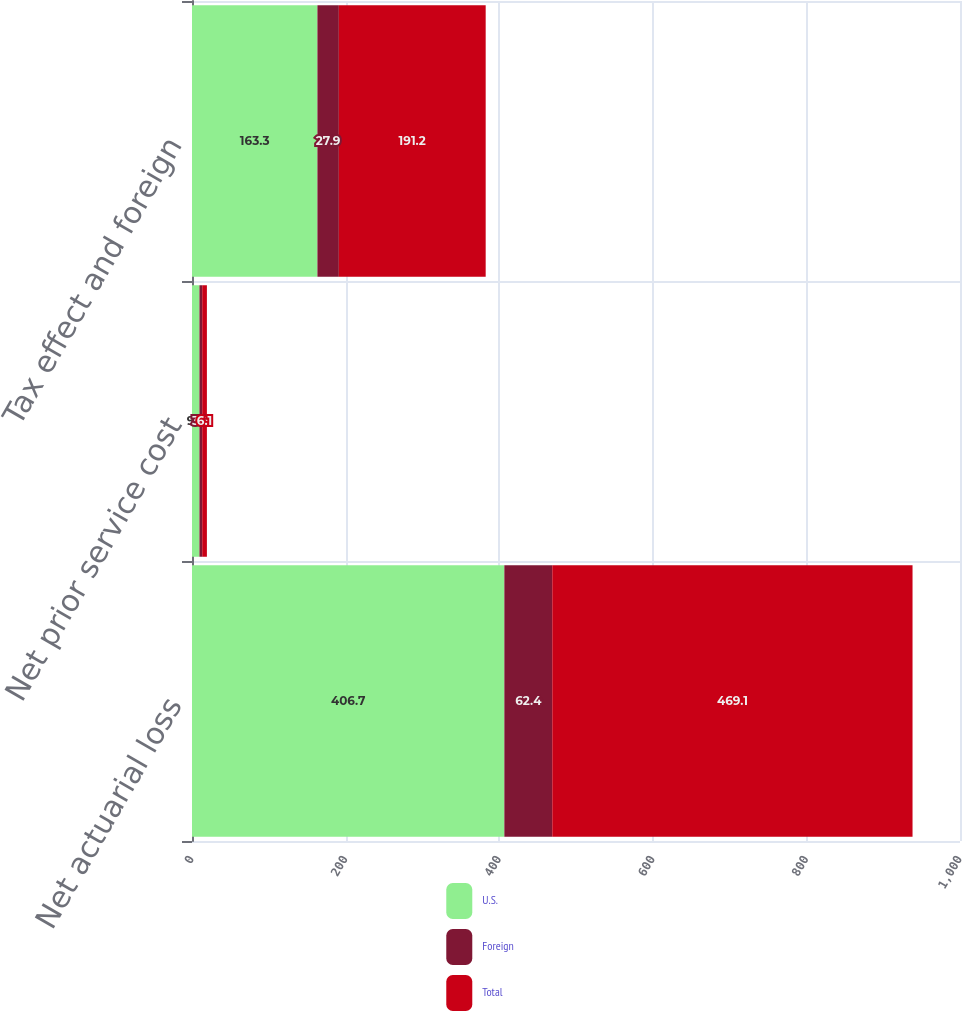Convert chart to OTSL. <chart><loc_0><loc_0><loc_500><loc_500><stacked_bar_chart><ecel><fcel>Net actuarial loss<fcel>Net prior service cost<fcel>Tax effect and foreign<nl><fcel>U.S.<fcel>406.7<fcel>9.7<fcel>163.3<nl><fcel>Foreign<fcel>62.4<fcel>3.6<fcel>27.9<nl><fcel>Total<fcel>469.1<fcel>6.1<fcel>191.2<nl></chart> 